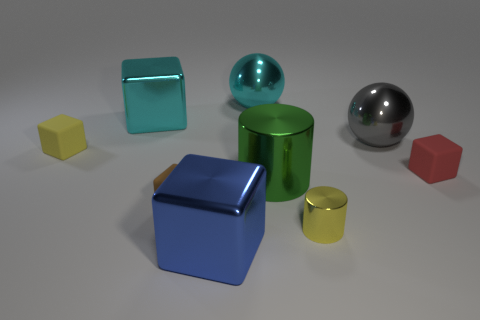Is the number of cyan cubes that are on the right side of the red object less than the number of yellow shiny objects in front of the large blue metal block?
Offer a terse response. No. How many blocks are on the left side of the cyan sphere?
Offer a terse response. 4. Is there a cyan object made of the same material as the tiny red cube?
Offer a terse response. No. Are there more yellow metallic cylinders right of the gray sphere than cyan balls right of the red object?
Offer a terse response. No. The cyan metallic cube is what size?
Give a very brief answer. Large. What shape is the tiny rubber thing behind the red rubber object?
Provide a succinct answer. Cube. Is the yellow rubber object the same shape as the gray object?
Your response must be concise. No. Are there the same number of big blue things that are right of the large gray metallic ball and yellow matte cubes?
Your response must be concise. No. What shape is the blue object?
Your answer should be compact. Cube. Are there any other things of the same color as the small metallic cylinder?
Make the answer very short. Yes. 